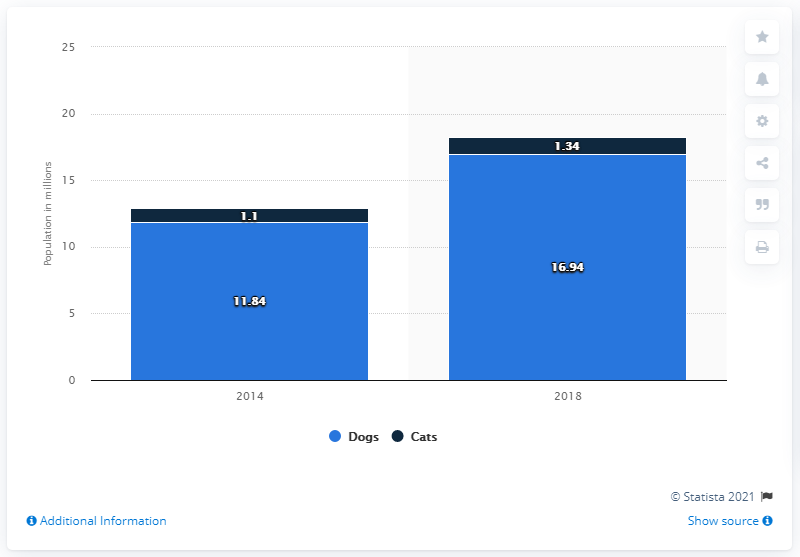Mention a couple of crucial points in this snapshot. In 2018, there were approximately 16.94 million households in India that owned dogs and cats. 